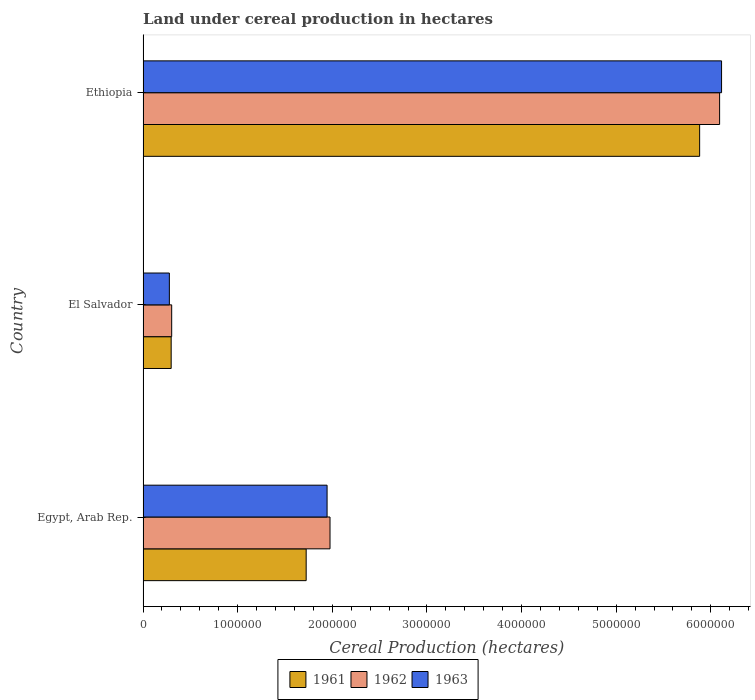What is the label of the 3rd group of bars from the top?
Keep it short and to the point. Egypt, Arab Rep. What is the land under cereal production in 1961 in Ethiopia?
Offer a terse response. 5.88e+06. Across all countries, what is the maximum land under cereal production in 1961?
Keep it short and to the point. 5.88e+06. Across all countries, what is the minimum land under cereal production in 1963?
Your answer should be compact. 2.78e+05. In which country was the land under cereal production in 1962 maximum?
Keep it short and to the point. Ethiopia. In which country was the land under cereal production in 1961 minimum?
Offer a very short reply. El Salvador. What is the total land under cereal production in 1962 in the graph?
Provide a short and direct response. 8.37e+06. What is the difference between the land under cereal production in 1963 in El Salvador and that in Ethiopia?
Provide a short and direct response. -5.84e+06. What is the difference between the land under cereal production in 1962 in Ethiopia and the land under cereal production in 1961 in Egypt, Arab Rep.?
Provide a succinct answer. 4.37e+06. What is the average land under cereal production in 1961 per country?
Your answer should be compact. 2.63e+06. What is the difference between the land under cereal production in 1962 and land under cereal production in 1961 in El Salvador?
Your answer should be compact. 5375. What is the ratio of the land under cereal production in 1962 in Egypt, Arab Rep. to that in Ethiopia?
Your answer should be very brief. 0.32. Is the land under cereal production in 1963 in El Salvador less than that in Ethiopia?
Offer a very short reply. Yes. Is the difference between the land under cereal production in 1962 in El Salvador and Ethiopia greater than the difference between the land under cereal production in 1961 in El Salvador and Ethiopia?
Give a very brief answer. No. What is the difference between the highest and the second highest land under cereal production in 1962?
Give a very brief answer. 4.12e+06. What is the difference between the highest and the lowest land under cereal production in 1962?
Offer a very short reply. 5.79e+06. What does the 1st bar from the top in El Salvador represents?
Give a very brief answer. 1963. What does the 3rd bar from the bottom in Ethiopia represents?
Offer a terse response. 1963. Are all the bars in the graph horizontal?
Offer a terse response. Yes. How many countries are there in the graph?
Your answer should be compact. 3. What is the difference between two consecutive major ticks on the X-axis?
Your response must be concise. 1.00e+06. Does the graph contain grids?
Make the answer very short. No. How are the legend labels stacked?
Give a very brief answer. Horizontal. What is the title of the graph?
Provide a succinct answer. Land under cereal production in hectares. Does "2004" appear as one of the legend labels in the graph?
Make the answer very short. No. What is the label or title of the X-axis?
Make the answer very short. Cereal Production (hectares). What is the Cereal Production (hectares) of 1961 in Egypt, Arab Rep.?
Ensure brevity in your answer.  1.72e+06. What is the Cereal Production (hectares) of 1962 in Egypt, Arab Rep.?
Your answer should be very brief. 1.98e+06. What is the Cereal Production (hectares) of 1963 in Egypt, Arab Rep.?
Offer a very short reply. 1.94e+06. What is the Cereal Production (hectares) in 1961 in El Salvador?
Your answer should be very brief. 2.97e+05. What is the Cereal Production (hectares) of 1962 in El Salvador?
Make the answer very short. 3.02e+05. What is the Cereal Production (hectares) in 1963 in El Salvador?
Give a very brief answer. 2.78e+05. What is the Cereal Production (hectares) of 1961 in Ethiopia?
Your response must be concise. 5.88e+06. What is the Cereal Production (hectares) in 1962 in Ethiopia?
Offer a terse response. 6.09e+06. What is the Cereal Production (hectares) of 1963 in Ethiopia?
Ensure brevity in your answer.  6.11e+06. Across all countries, what is the maximum Cereal Production (hectares) in 1961?
Your response must be concise. 5.88e+06. Across all countries, what is the maximum Cereal Production (hectares) in 1962?
Offer a very short reply. 6.09e+06. Across all countries, what is the maximum Cereal Production (hectares) in 1963?
Your answer should be compact. 6.11e+06. Across all countries, what is the minimum Cereal Production (hectares) in 1961?
Give a very brief answer. 2.97e+05. Across all countries, what is the minimum Cereal Production (hectares) in 1962?
Give a very brief answer. 3.02e+05. Across all countries, what is the minimum Cereal Production (hectares) of 1963?
Provide a succinct answer. 2.78e+05. What is the total Cereal Production (hectares) of 1961 in the graph?
Provide a succinct answer. 7.90e+06. What is the total Cereal Production (hectares) in 1962 in the graph?
Offer a terse response. 8.37e+06. What is the total Cereal Production (hectares) of 1963 in the graph?
Offer a terse response. 8.34e+06. What is the difference between the Cereal Production (hectares) in 1961 in Egypt, Arab Rep. and that in El Salvador?
Your answer should be compact. 1.43e+06. What is the difference between the Cereal Production (hectares) of 1962 in Egypt, Arab Rep. and that in El Salvador?
Give a very brief answer. 1.67e+06. What is the difference between the Cereal Production (hectares) of 1963 in Egypt, Arab Rep. and that in El Salvador?
Keep it short and to the point. 1.67e+06. What is the difference between the Cereal Production (hectares) in 1961 in Egypt, Arab Rep. and that in Ethiopia?
Provide a short and direct response. -4.16e+06. What is the difference between the Cereal Production (hectares) in 1962 in Egypt, Arab Rep. and that in Ethiopia?
Ensure brevity in your answer.  -4.12e+06. What is the difference between the Cereal Production (hectares) in 1963 in Egypt, Arab Rep. and that in Ethiopia?
Your answer should be very brief. -4.17e+06. What is the difference between the Cereal Production (hectares) in 1961 in El Salvador and that in Ethiopia?
Your answer should be compact. -5.58e+06. What is the difference between the Cereal Production (hectares) of 1962 in El Salvador and that in Ethiopia?
Provide a short and direct response. -5.79e+06. What is the difference between the Cereal Production (hectares) in 1963 in El Salvador and that in Ethiopia?
Your response must be concise. -5.84e+06. What is the difference between the Cereal Production (hectares) in 1961 in Egypt, Arab Rep. and the Cereal Production (hectares) in 1962 in El Salvador?
Provide a short and direct response. 1.42e+06. What is the difference between the Cereal Production (hectares) in 1961 in Egypt, Arab Rep. and the Cereal Production (hectares) in 1963 in El Salvador?
Ensure brevity in your answer.  1.45e+06. What is the difference between the Cereal Production (hectares) of 1962 in Egypt, Arab Rep. and the Cereal Production (hectares) of 1963 in El Salvador?
Give a very brief answer. 1.70e+06. What is the difference between the Cereal Production (hectares) of 1961 in Egypt, Arab Rep. and the Cereal Production (hectares) of 1962 in Ethiopia?
Keep it short and to the point. -4.37e+06. What is the difference between the Cereal Production (hectares) in 1961 in Egypt, Arab Rep. and the Cereal Production (hectares) in 1963 in Ethiopia?
Your answer should be compact. -4.39e+06. What is the difference between the Cereal Production (hectares) in 1962 in Egypt, Arab Rep. and the Cereal Production (hectares) in 1963 in Ethiopia?
Offer a very short reply. -4.14e+06. What is the difference between the Cereal Production (hectares) of 1961 in El Salvador and the Cereal Production (hectares) of 1962 in Ethiopia?
Ensure brevity in your answer.  -5.80e+06. What is the difference between the Cereal Production (hectares) in 1961 in El Salvador and the Cereal Production (hectares) in 1963 in Ethiopia?
Provide a short and direct response. -5.82e+06. What is the difference between the Cereal Production (hectares) of 1962 in El Salvador and the Cereal Production (hectares) of 1963 in Ethiopia?
Offer a very short reply. -5.81e+06. What is the average Cereal Production (hectares) in 1961 per country?
Your response must be concise. 2.63e+06. What is the average Cereal Production (hectares) in 1962 per country?
Give a very brief answer. 2.79e+06. What is the average Cereal Production (hectares) of 1963 per country?
Provide a short and direct response. 2.78e+06. What is the difference between the Cereal Production (hectares) of 1961 and Cereal Production (hectares) of 1962 in Egypt, Arab Rep.?
Ensure brevity in your answer.  -2.52e+05. What is the difference between the Cereal Production (hectares) in 1961 and Cereal Production (hectares) in 1963 in Egypt, Arab Rep.?
Provide a short and direct response. -2.21e+05. What is the difference between the Cereal Production (hectares) in 1962 and Cereal Production (hectares) in 1963 in Egypt, Arab Rep.?
Your answer should be compact. 3.10e+04. What is the difference between the Cereal Production (hectares) in 1961 and Cereal Production (hectares) in 1962 in El Salvador?
Ensure brevity in your answer.  -5375. What is the difference between the Cereal Production (hectares) of 1961 and Cereal Production (hectares) of 1963 in El Salvador?
Keep it short and to the point. 1.92e+04. What is the difference between the Cereal Production (hectares) of 1962 and Cereal Production (hectares) of 1963 in El Salvador?
Keep it short and to the point. 2.46e+04. What is the difference between the Cereal Production (hectares) of 1961 and Cereal Production (hectares) of 1962 in Ethiopia?
Your response must be concise. -2.11e+05. What is the difference between the Cereal Production (hectares) in 1961 and Cereal Production (hectares) in 1963 in Ethiopia?
Your response must be concise. -2.32e+05. What is the difference between the Cereal Production (hectares) of 1962 and Cereal Production (hectares) of 1963 in Ethiopia?
Keep it short and to the point. -2.07e+04. What is the ratio of the Cereal Production (hectares) of 1961 in Egypt, Arab Rep. to that in El Salvador?
Your answer should be compact. 5.8. What is the ratio of the Cereal Production (hectares) in 1962 in Egypt, Arab Rep. to that in El Salvador?
Provide a succinct answer. 6.53. What is the ratio of the Cereal Production (hectares) in 1963 in Egypt, Arab Rep. to that in El Salvador?
Your response must be concise. 7. What is the ratio of the Cereal Production (hectares) of 1961 in Egypt, Arab Rep. to that in Ethiopia?
Offer a terse response. 0.29. What is the ratio of the Cereal Production (hectares) of 1962 in Egypt, Arab Rep. to that in Ethiopia?
Your answer should be compact. 0.32. What is the ratio of the Cereal Production (hectares) of 1963 in Egypt, Arab Rep. to that in Ethiopia?
Offer a very short reply. 0.32. What is the ratio of the Cereal Production (hectares) in 1961 in El Salvador to that in Ethiopia?
Your answer should be very brief. 0.05. What is the ratio of the Cereal Production (hectares) in 1962 in El Salvador to that in Ethiopia?
Provide a succinct answer. 0.05. What is the ratio of the Cereal Production (hectares) in 1963 in El Salvador to that in Ethiopia?
Offer a very short reply. 0.05. What is the difference between the highest and the second highest Cereal Production (hectares) in 1961?
Provide a succinct answer. 4.16e+06. What is the difference between the highest and the second highest Cereal Production (hectares) in 1962?
Provide a short and direct response. 4.12e+06. What is the difference between the highest and the second highest Cereal Production (hectares) in 1963?
Make the answer very short. 4.17e+06. What is the difference between the highest and the lowest Cereal Production (hectares) of 1961?
Give a very brief answer. 5.58e+06. What is the difference between the highest and the lowest Cereal Production (hectares) of 1962?
Keep it short and to the point. 5.79e+06. What is the difference between the highest and the lowest Cereal Production (hectares) of 1963?
Your answer should be compact. 5.84e+06. 